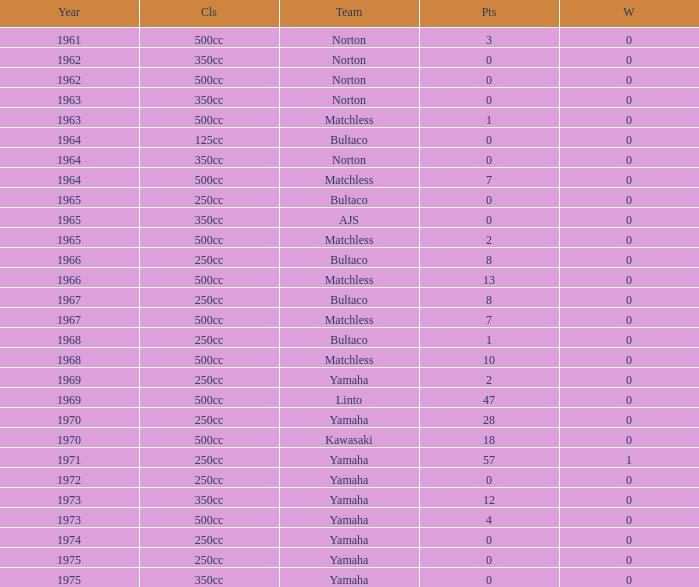Which class corresponds to more than 2 points, wins greater than 0, and a year earlier than 1973? 250cc. 